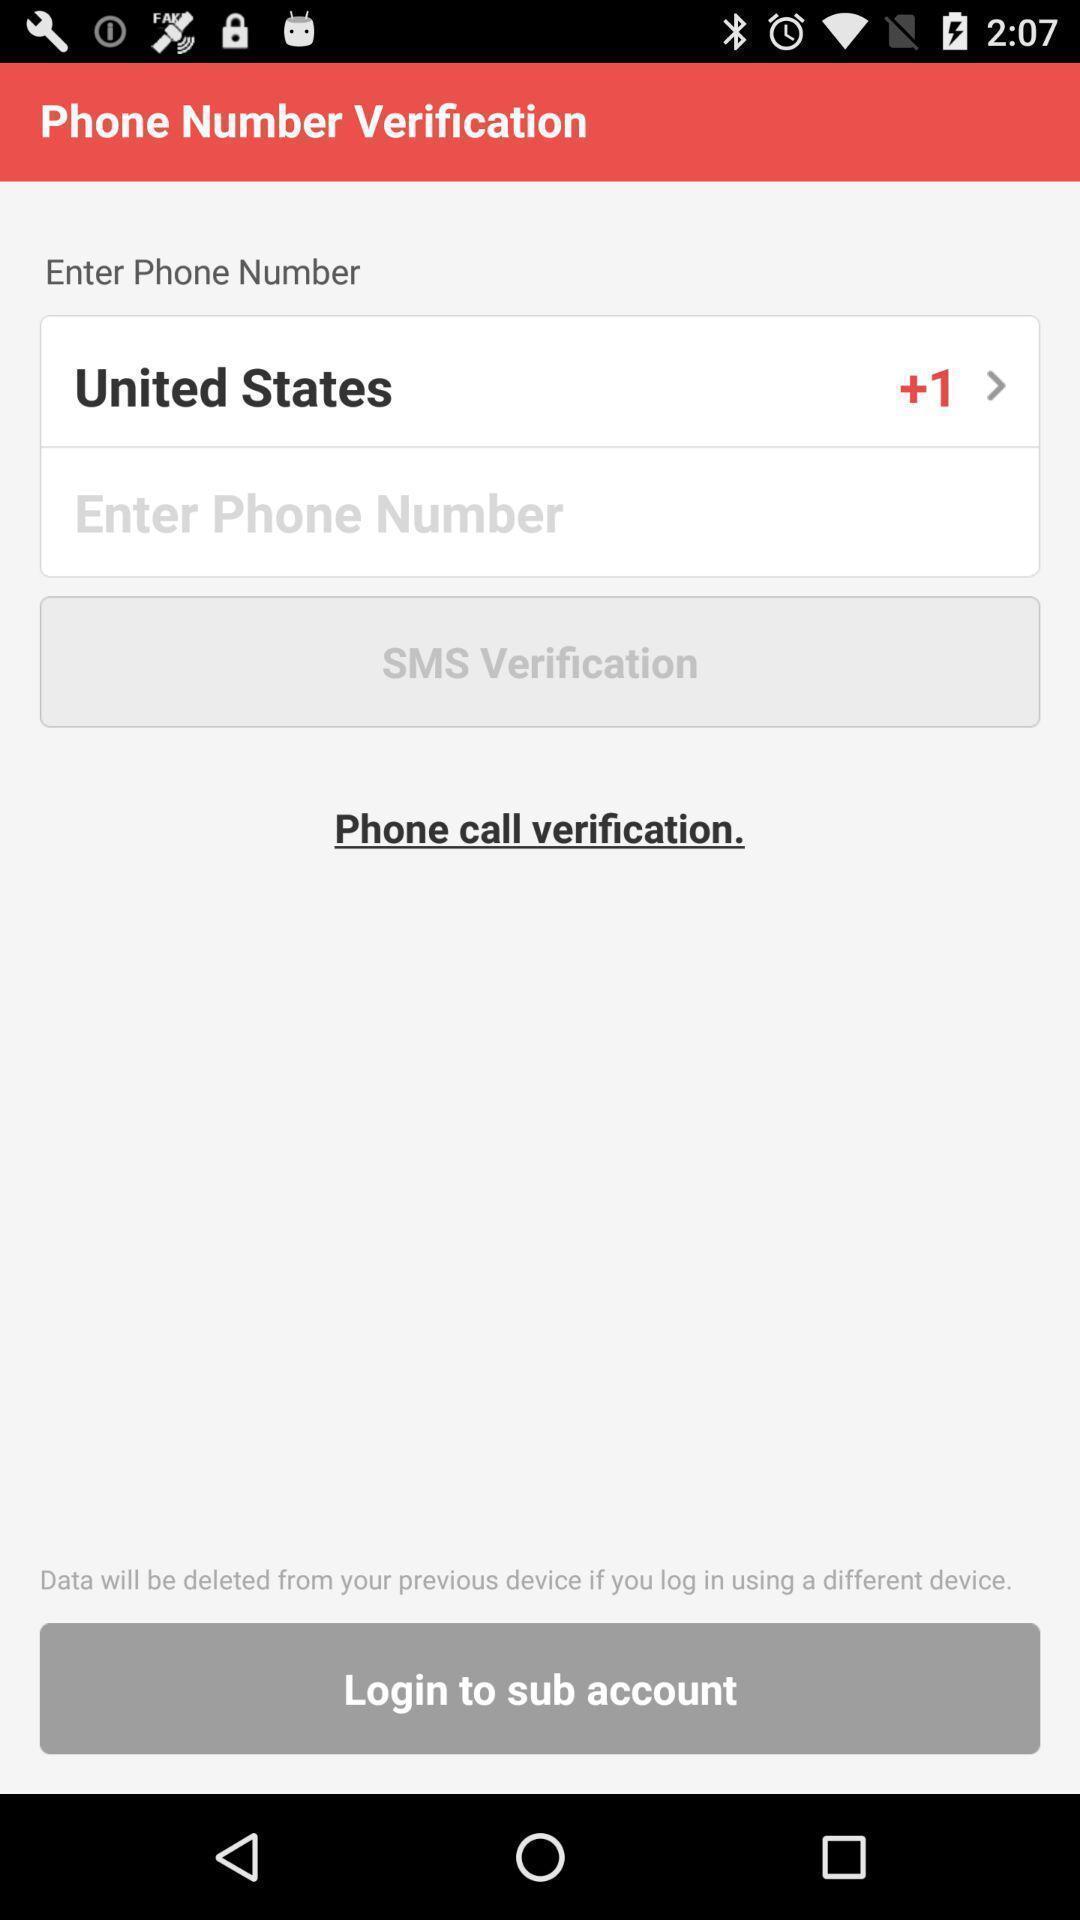What can you discern from this picture? Verification page of a chatting app. 